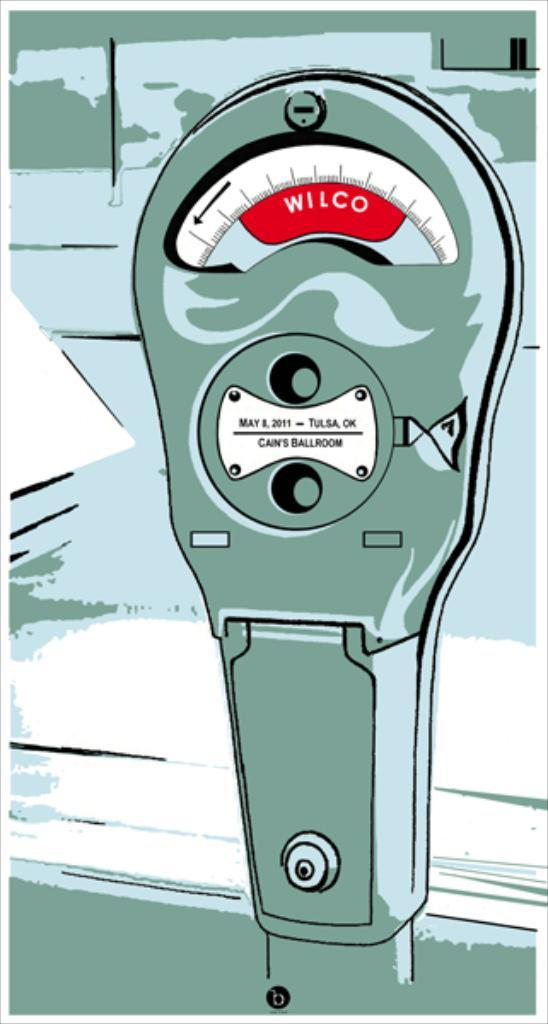<image>
Share a concise interpretation of the image provided. A drawing of a parking meter says Wilco on it. 